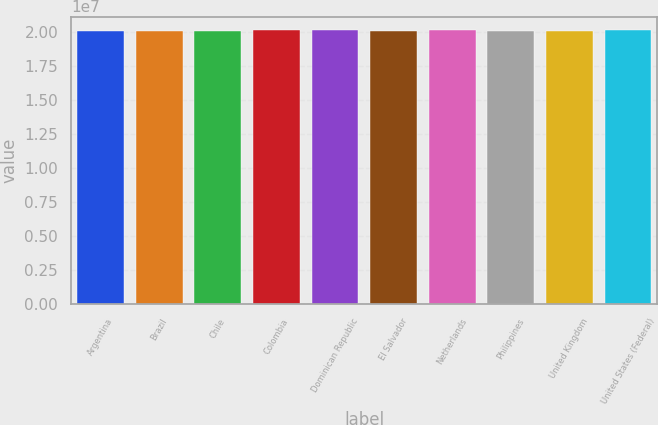Convert chart. <chart><loc_0><loc_0><loc_500><loc_500><bar_chart><fcel>Argentina<fcel>Brazil<fcel>Chile<fcel>Colombia<fcel>Dominican Republic<fcel>El Salvador<fcel>Netherlands<fcel>Philippines<fcel>United Kingdom<fcel>United States (Federal)<nl><fcel>2.0112e+07<fcel>2.0122e+07<fcel>2.0142e+07<fcel>2.0158e+07<fcel>2.0162e+07<fcel>2.0146e+07<fcel>2.015e+07<fcel>2.0132e+07<fcel>2.0126e+07<fcel>2.0154e+07<nl></chart> 